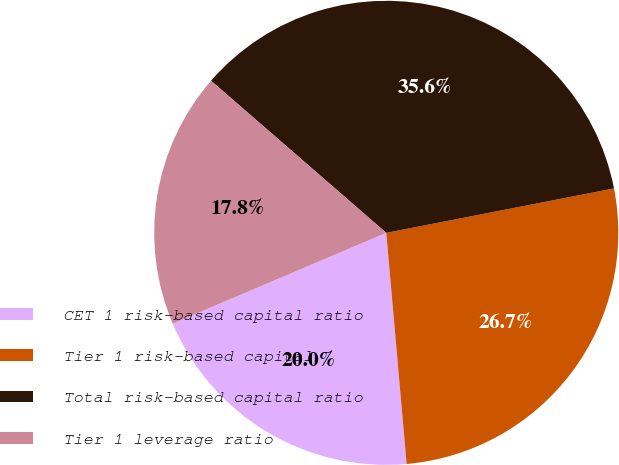<chart> <loc_0><loc_0><loc_500><loc_500><pie_chart><fcel>CET 1 risk-based capital ratio<fcel>Tier 1 risk-based capital<fcel>Total risk-based capital ratio<fcel>Tier 1 leverage ratio<nl><fcel>20.0%<fcel>26.67%<fcel>35.56%<fcel>17.78%<nl></chart> 